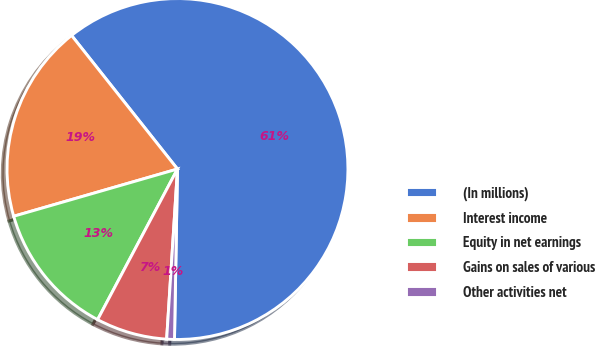<chart> <loc_0><loc_0><loc_500><loc_500><pie_chart><fcel>(In millions)<fcel>Interest income<fcel>Equity in net earnings<fcel>Gains on sales of various<fcel>Other activities net<nl><fcel>60.95%<fcel>18.8%<fcel>12.77%<fcel>6.75%<fcel>0.73%<nl></chart> 